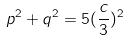<formula> <loc_0><loc_0><loc_500><loc_500>p ^ { 2 } + q ^ { 2 } = 5 ( \frac { c } { 3 } ) ^ { 2 }</formula> 